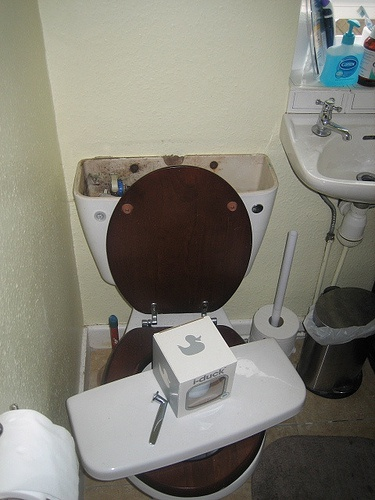Describe the objects in this image and their specific colors. I can see toilet in gray, black, and darkgray tones and sink in gray, darkgray, and black tones in this image. 